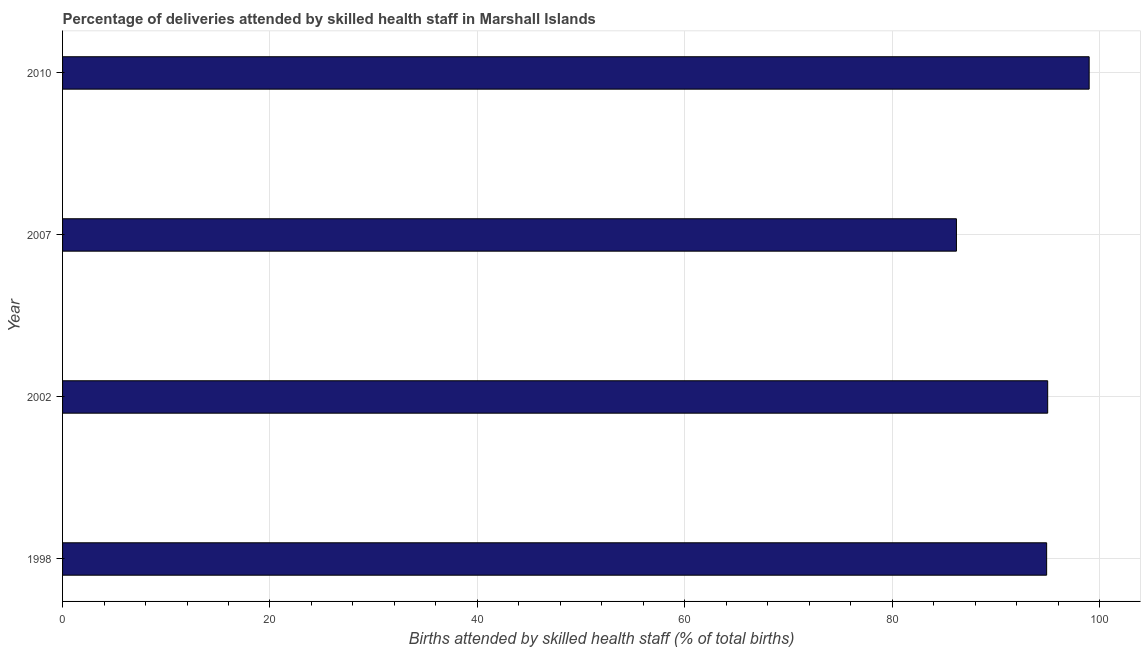Does the graph contain any zero values?
Keep it short and to the point. No. Does the graph contain grids?
Provide a short and direct response. Yes. What is the title of the graph?
Give a very brief answer. Percentage of deliveries attended by skilled health staff in Marshall Islands. What is the label or title of the X-axis?
Give a very brief answer. Births attended by skilled health staff (% of total births). What is the label or title of the Y-axis?
Offer a very short reply. Year. Across all years, what is the maximum number of births attended by skilled health staff?
Provide a succinct answer. 99. Across all years, what is the minimum number of births attended by skilled health staff?
Your response must be concise. 86.2. In which year was the number of births attended by skilled health staff maximum?
Provide a succinct answer. 2010. In which year was the number of births attended by skilled health staff minimum?
Provide a succinct answer. 2007. What is the sum of the number of births attended by skilled health staff?
Offer a terse response. 375.1. What is the average number of births attended by skilled health staff per year?
Provide a succinct answer. 93.78. What is the median number of births attended by skilled health staff?
Keep it short and to the point. 94.95. Do a majority of the years between 2002 and 2010 (inclusive) have number of births attended by skilled health staff greater than 32 %?
Offer a very short reply. Yes. What is the ratio of the number of births attended by skilled health staff in 2002 to that in 2007?
Give a very brief answer. 1.1. Is the number of births attended by skilled health staff in 1998 less than that in 2010?
Provide a short and direct response. Yes. Is the difference between the number of births attended by skilled health staff in 2002 and 2007 greater than the difference between any two years?
Keep it short and to the point. No. What is the difference between the highest and the second highest number of births attended by skilled health staff?
Provide a short and direct response. 4. Is the sum of the number of births attended by skilled health staff in 1998 and 2002 greater than the maximum number of births attended by skilled health staff across all years?
Make the answer very short. Yes. What is the difference between the highest and the lowest number of births attended by skilled health staff?
Give a very brief answer. 12.8. In how many years, is the number of births attended by skilled health staff greater than the average number of births attended by skilled health staff taken over all years?
Make the answer very short. 3. Are all the bars in the graph horizontal?
Provide a short and direct response. Yes. What is the difference between two consecutive major ticks on the X-axis?
Your answer should be compact. 20. What is the Births attended by skilled health staff (% of total births) in 1998?
Offer a very short reply. 94.9. What is the Births attended by skilled health staff (% of total births) in 2007?
Ensure brevity in your answer.  86.2. What is the Births attended by skilled health staff (% of total births) of 2010?
Your answer should be compact. 99. What is the difference between the Births attended by skilled health staff (% of total births) in 1998 and 2002?
Provide a succinct answer. -0.1. What is the difference between the Births attended by skilled health staff (% of total births) in 1998 and 2010?
Ensure brevity in your answer.  -4.1. What is the difference between the Births attended by skilled health staff (% of total births) in 2002 and 2010?
Offer a terse response. -4. What is the difference between the Births attended by skilled health staff (% of total births) in 2007 and 2010?
Make the answer very short. -12.8. What is the ratio of the Births attended by skilled health staff (% of total births) in 1998 to that in 2002?
Offer a terse response. 1. What is the ratio of the Births attended by skilled health staff (% of total births) in 1998 to that in 2007?
Make the answer very short. 1.1. What is the ratio of the Births attended by skilled health staff (% of total births) in 1998 to that in 2010?
Offer a terse response. 0.96. What is the ratio of the Births attended by skilled health staff (% of total births) in 2002 to that in 2007?
Ensure brevity in your answer.  1.1. What is the ratio of the Births attended by skilled health staff (% of total births) in 2002 to that in 2010?
Offer a very short reply. 0.96. What is the ratio of the Births attended by skilled health staff (% of total births) in 2007 to that in 2010?
Give a very brief answer. 0.87. 